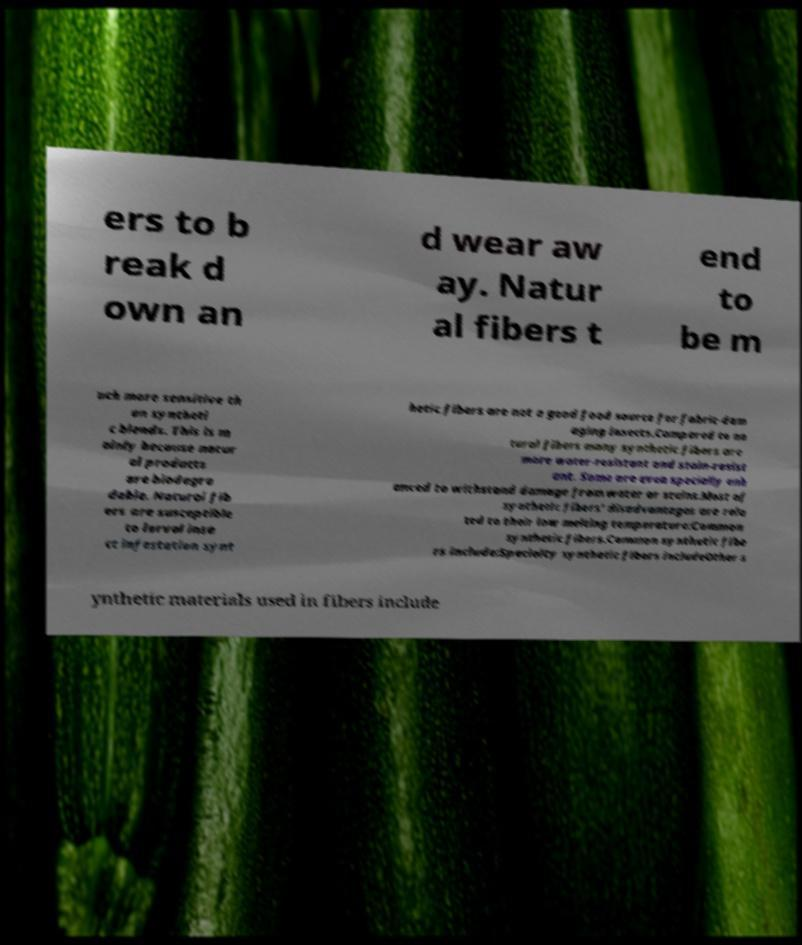Can you read and provide the text displayed in the image?This photo seems to have some interesting text. Can you extract and type it out for me? ers to b reak d own an d wear aw ay. Natur al fibers t end to be m uch more sensitive th an syntheti c blends. This is m ainly because natur al products are biodegra dable. Natural fib ers are susceptible to larval inse ct infestation synt hetic fibers are not a good food source for fabric-dam aging insects.Compared to na tural fibers many synthetic fibers are more water-resistant and stain-resist ant. Some are even specially enh anced to withstand damage from water or stains.Most of synthetic fibers' disadvantages are rela ted to their low melting temperature:Common synthetic fibers.Common synthetic fibe rs include:Specialty synthetic fibers includeOther s ynthetic materials used in fibers include 